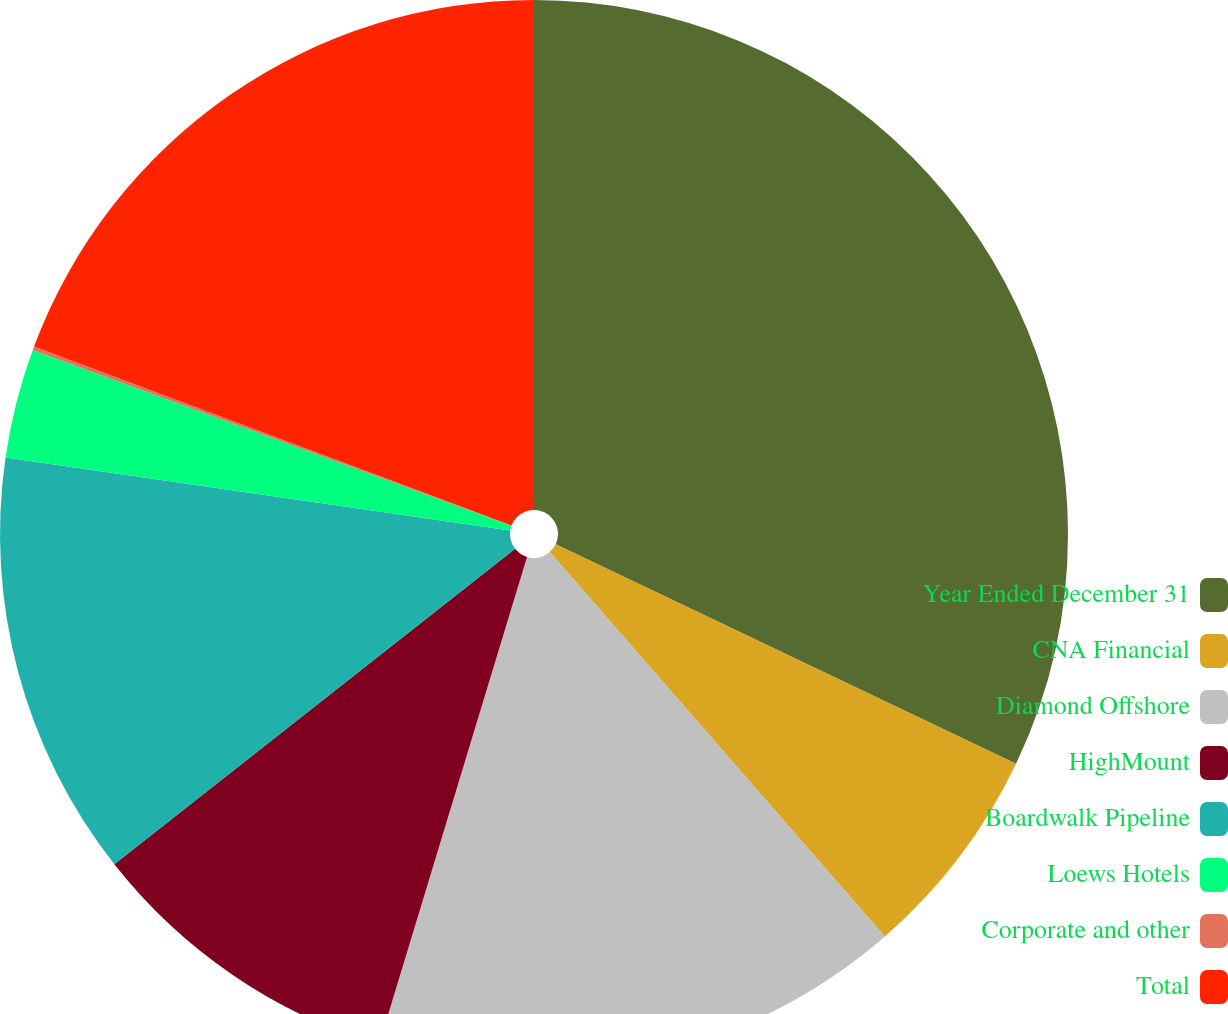<chart> <loc_0><loc_0><loc_500><loc_500><pie_chart><fcel>Year Ended December 31<fcel>CNA Financial<fcel>Diamond Offshore<fcel>HighMount<fcel>Boardwalk Pipeline<fcel>Loews Hotels<fcel>Corporate and other<fcel>Total<nl><fcel>32.08%<fcel>6.51%<fcel>16.1%<fcel>9.7%<fcel>12.9%<fcel>3.31%<fcel>0.11%<fcel>19.29%<nl></chart> 